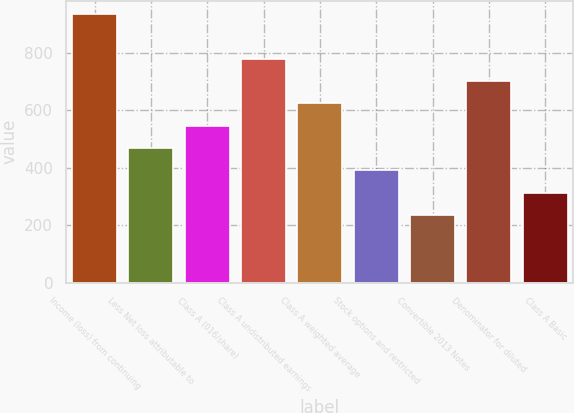Convert chart. <chart><loc_0><loc_0><loc_500><loc_500><bar_chart><fcel>Income (loss) from continuing<fcel>Less Net loss attributable to<fcel>Class A (016/share)<fcel>Class A undistributed earnings<fcel>Class A weighted average<fcel>Stock options and restricted<fcel>Convertible 2013 Notes<fcel>Denominator for diluted<fcel>Class A Basic<nl><fcel>935.63<fcel>468.77<fcel>546.58<fcel>780.01<fcel>624.39<fcel>390.96<fcel>235.34<fcel>702.2<fcel>313.15<nl></chart> 